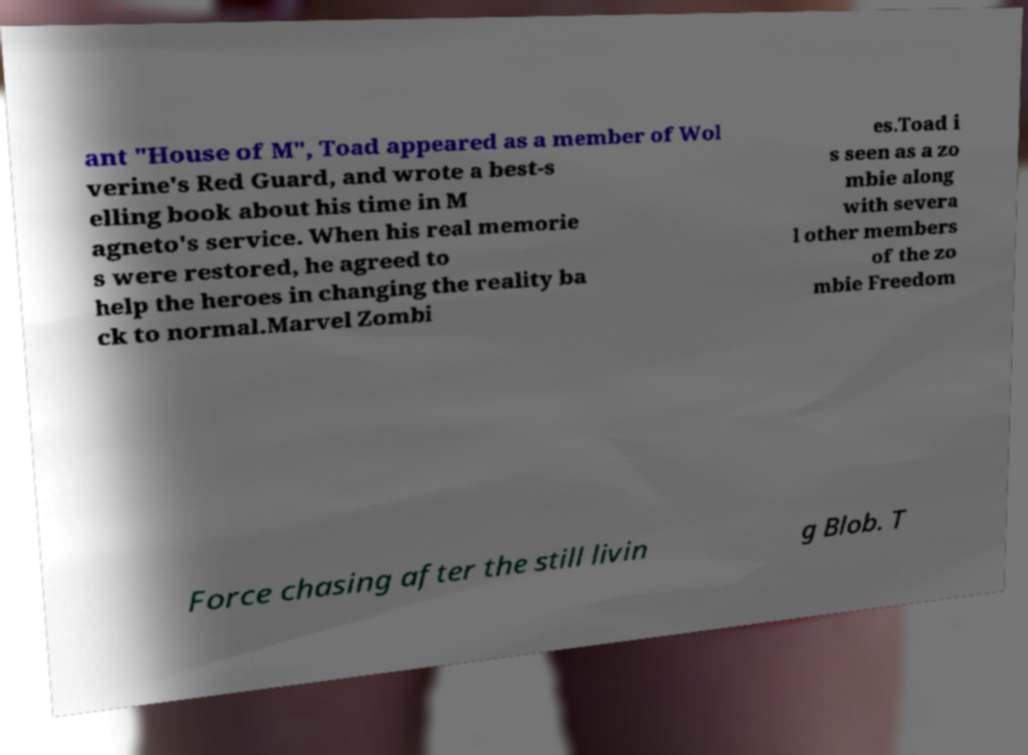Could you assist in decoding the text presented in this image and type it out clearly? ant "House of M", Toad appeared as a member of Wol verine's Red Guard, and wrote a best-s elling book about his time in M agneto's service. When his real memorie s were restored, he agreed to help the heroes in changing the reality ba ck to normal.Marvel Zombi es.Toad i s seen as a zo mbie along with severa l other members of the zo mbie Freedom Force chasing after the still livin g Blob. T 